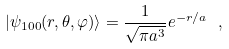Convert formula to latex. <formula><loc_0><loc_0><loc_500><loc_500>| \psi _ { 1 0 0 } ( r , \theta , \varphi ) \rangle = \frac { 1 } { \sqrt { \pi a ^ { 3 } } } e ^ { - r / a } \ ,</formula> 